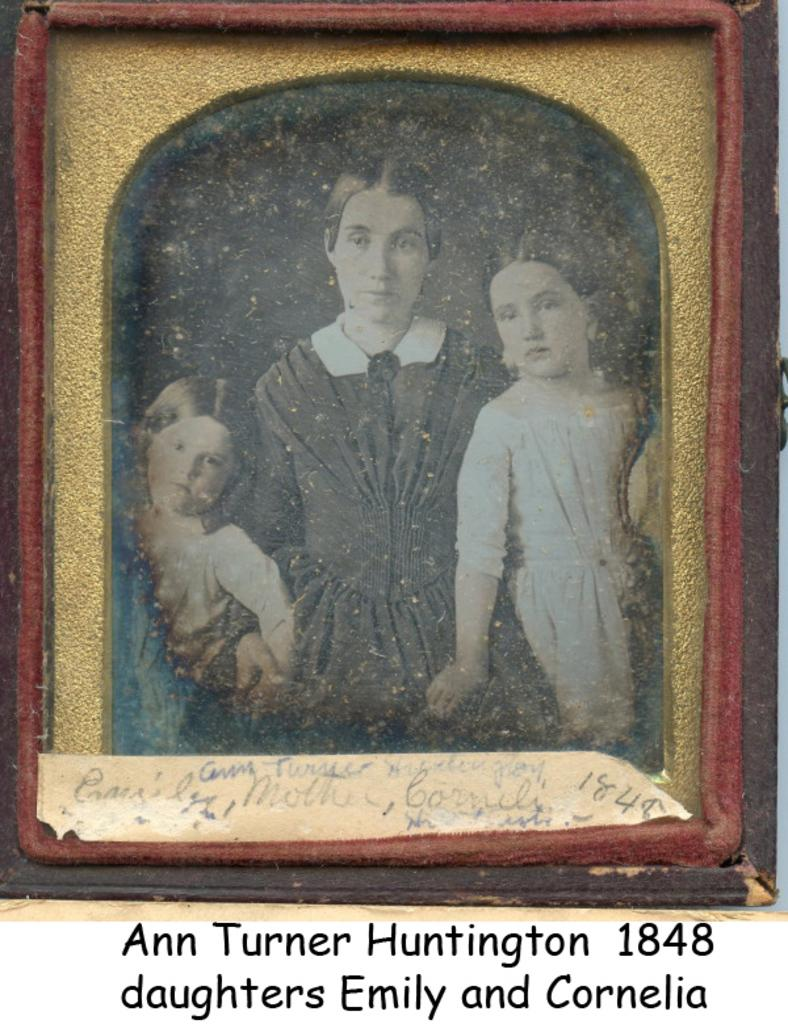What is the main object in the image? There is a frame in the image. Who or what is inside the frame? A woman and two children are present in the frame. Is there any text associated with the image? Yes, there is some text at the bottom of the frame and the picture. How many fingers can be seen blowing on the cake in the image? There is no cake or fingers blowing on it in the image. 